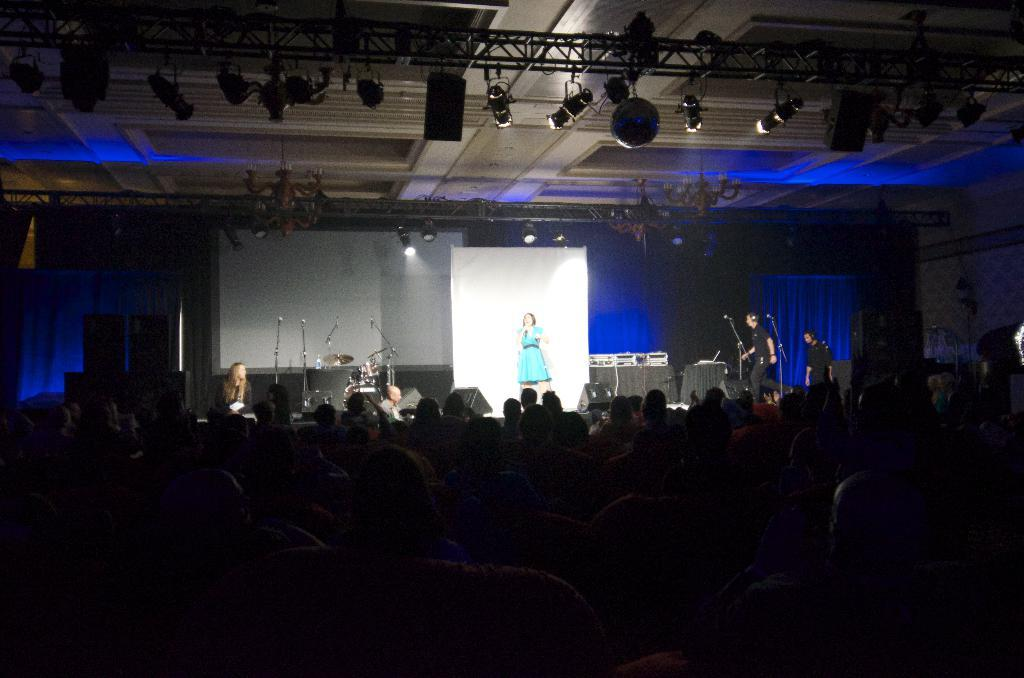What are the people in the image doing? The people in the image are sitting. What can be seen on the stage in the image? There are microphones on the stage. What is visible at the top of the image? There are lights visible at the top of the image. How many fish can be seen swimming in the sea in the image? There are no fish or sea visible in the image. 